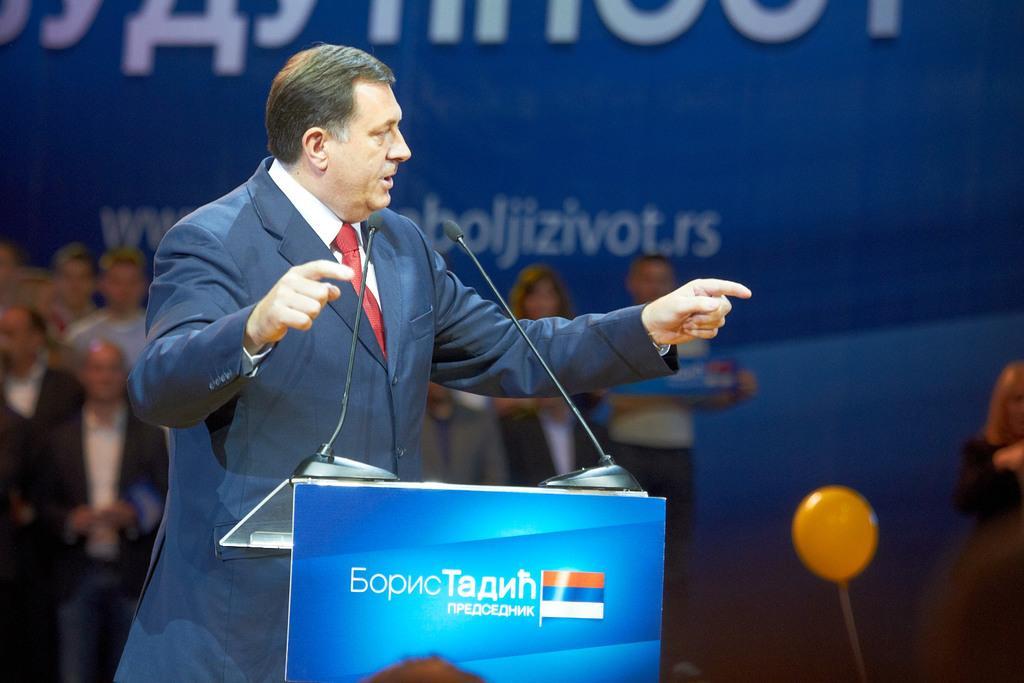Please provide a concise description of this image. In this picture I can see there is a man standing, he is wearing a blazer, there is a podium in front of him with two microphones and there are a few people standing and there is a banner in the backdrop and there is something written on it. 